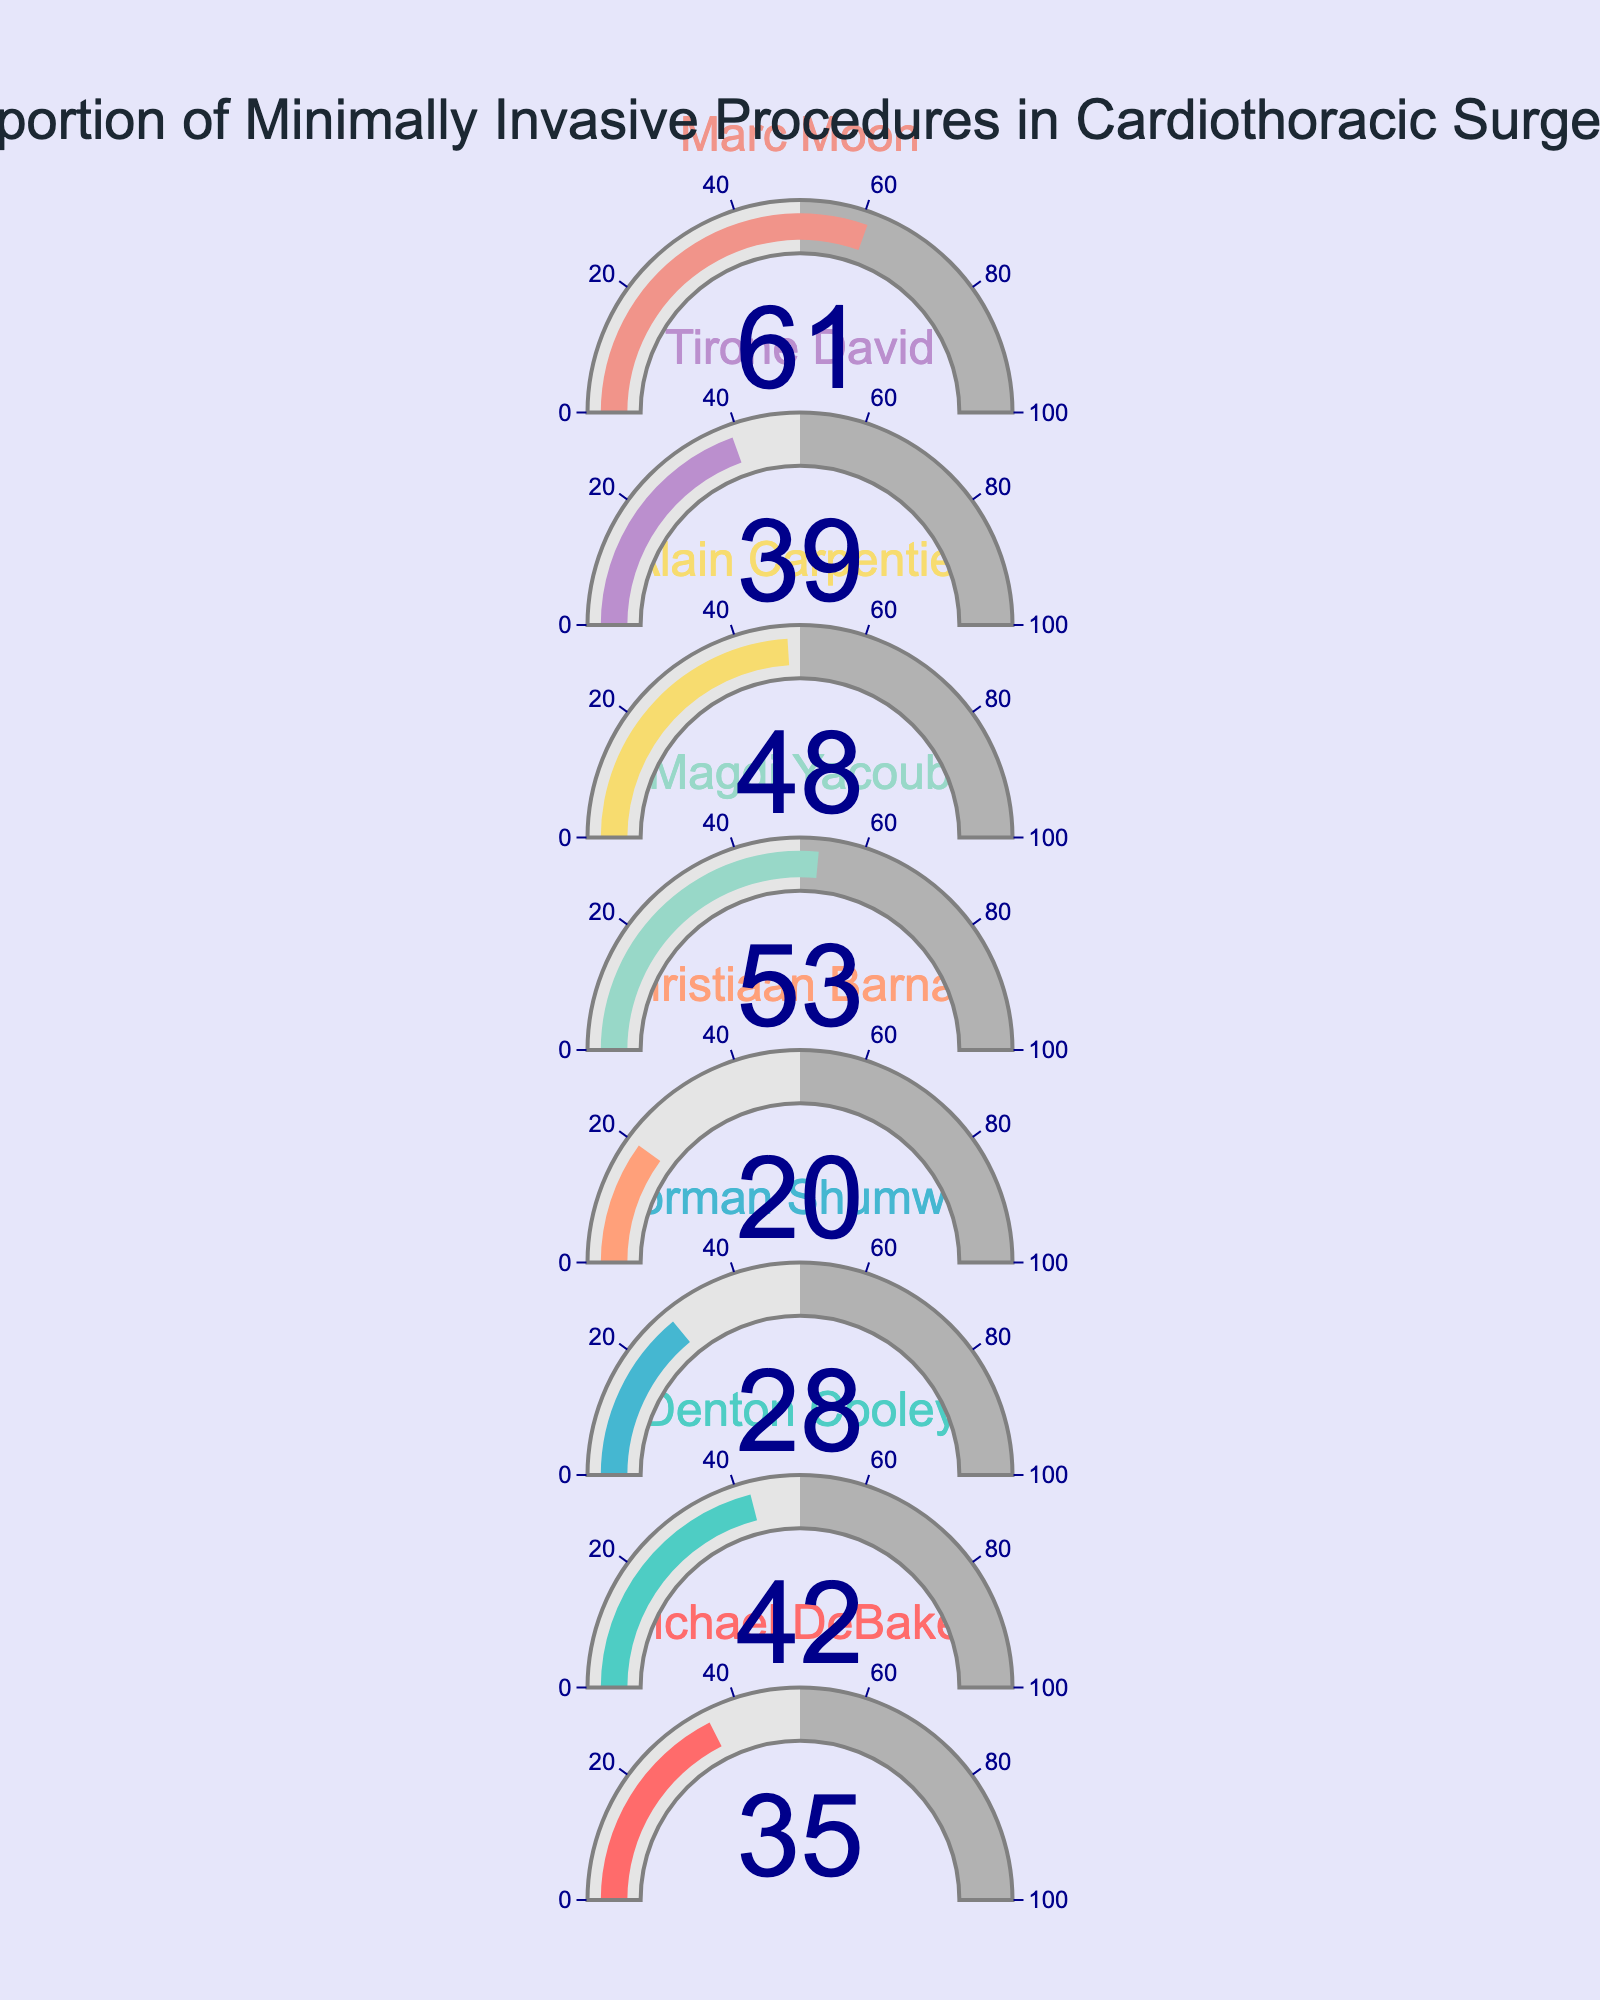How many surgeons are represented in the figure? Count the number of distinct gauge indicators, which correspond to the number of surgeons presented.
Answer: 8 Which surgeon has the highest proportion of minimally invasive procedures? Identify the gauge indicator with the highest value. In this case, Marc Moon’s gauge reads the maximum value of 61%.
Answer: Marc Moon What is the average proportion of minimally invasive procedures among the surgeons? Add the proportions of all surgeons and divide the sum by the number of surgeons: (35 + 42 + 28 + 20 + 53 + 48 + 39 + 61) / 8 = 40.75%.
Answer: 40.75% Who has a higher proportion of minimally invasive procedures, Christiaan Barnard or Norman Shumway? Compare the values on the gauges for Christiaan Barnard (20%) and Norman Shumway (28%).
Answer: Norman Shumway Which surgeon's gauge indicator is colored in dark blue? Look for the gauge with a title font color of "dark blue." In the provided list, no specific surgeon uses "dark blue" as a title font color, but the gauge axis ticks are dark blue across all gauges.
Answer: None What is the combined proportion of minimally invasive procedures for Denton Cooley and Magdi Yacoub? Add the proportions for both surgeons: 42% for Denton Cooley and 53% for Magdi Yacoub, resulting in 42 + 53 = 95%.
Answer: 95% Is the proportion of minimally invasive procedures for Michael DeBakey greater than 30%? Check the gauge's value for Michael DeBakey, which is 35%, and compare it to 30%.
Answer: Yes Arrange surgeons in ascending order of their proportion of minimally invasive procedures. Read and sort the gauge values: Christiaan Barnard (20%), Norman Shumway (28%), Michael DeBakey (35%), Tirone David (39%), Denton Cooley (42%), Alain Carpentier (48%), Magdi Yacoub (53%), Marc Moon (61%).
Answer: Christiaan Barnard, Norman Shumway, Michael DeBakey, Tirone David, Denton Cooley, Alain Carpentier, Magdi Yacoub, Marc Moon What is the difference in the proportion of minimally invasive procedures between Alain Carpentier and Tirone David? Subtract the proportion value of Tirone David (39%) from Alain Carpentier’s (48%): 48 - 39 = 9%.
Answer: 9% 